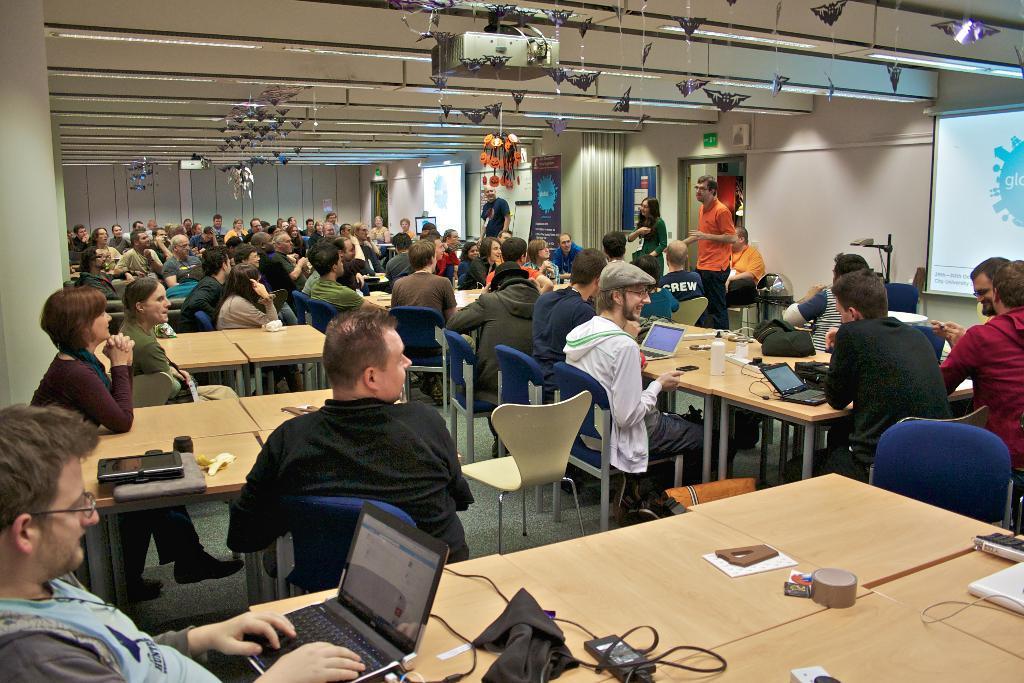In one or two sentences, can you explain what this image depicts? There is a room. There is a group of people. They are sitting on a chairs. Three persons are standing. There is a table. There is a laptop,glass,ipad,paper,battery ,cloth on a table. We can see in background curtain and protector. 